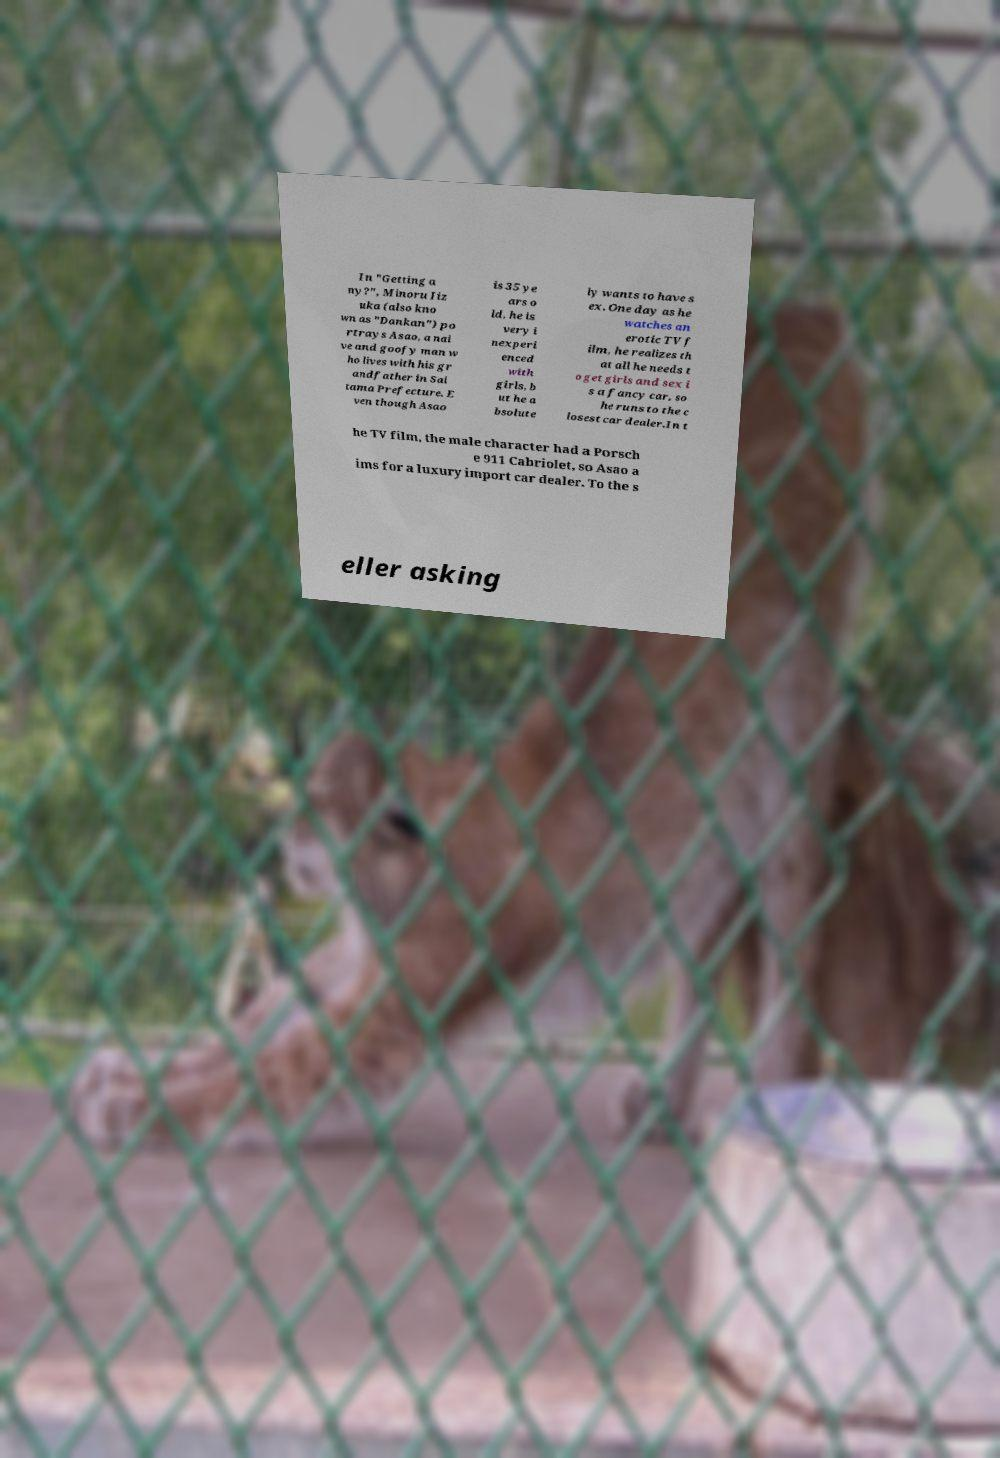Please read and relay the text visible in this image. What does it say? In "Getting a ny?", Minoru Iiz uka (also kno wn as "Dankan") po rtrays Asao, a nai ve and goofy man w ho lives with his gr andfather in Sai tama Prefecture. E ven though Asao is 35 ye ars o ld, he is very i nexperi enced with girls, b ut he a bsolute ly wants to have s ex. One day as he watches an erotic TV f ilm, he realizes th at all he needs t o get girls and sex i s a fancy car, so he runs to the c losest car dealer.In t he TV film, the male character had a Porsch e 911 Cabriolet, so Asao a ims for a luxury import car dealer. To the s eller asking 